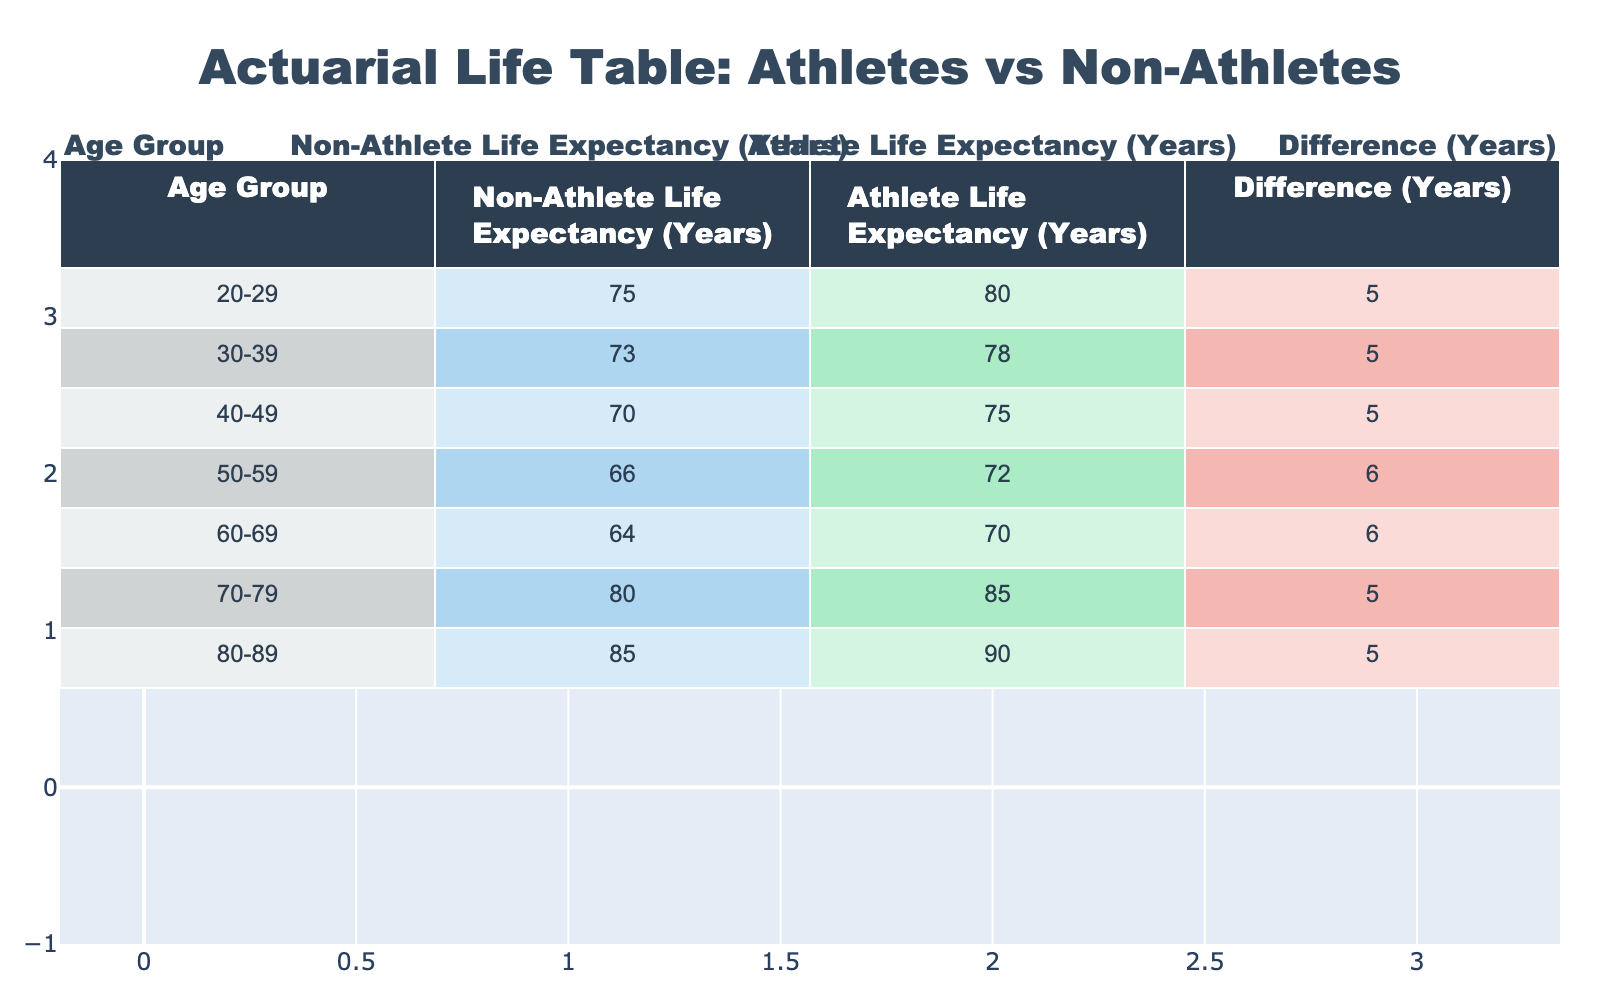What is the life expectancy of athletes in the age group 50-59? From the table, we can see the row corresponding to the age group 50-59. In that row, the value under "Athlete Life Expectancy" is 72 years.
Answer: 72 What is the life expectancy difference between athletes and non-athletes in the age group 30-39? In the table, for the age group 30-39, the "Difference" column shows a value of 5 years, indicating that athletes live 5 years longer on average than non-athletes in this age group.
Answer: 5 Is the life expectancy for non-athletes in the age group 60-69 greater than 65 years? Looking at the "Non-Athlete Life Expectancy" for the age group 60-69, the value is 64 years, which is less than 65. Therefore, the statement is false.
Answer: No Which age group shows the greatest difference in life expectancy between athletes and non-athletes? To find the greatest difference, we need to examine the "Difference" column and identify the maximum value. The maximum value is 6 years, seen in the age groups 50-59 and 60-69. Both groups reflect this greatest difference.
Answer: 50-59 and 60-69 What is the average life expectancy of non-athletes across all age groups? First, sum the non-athlete life expectancies: 75 + 73 + 70 + 66 + 64 + 80 + 85 = 513. There are 7 age groups, so to find the average, divide 513 by 7, giving about 73.29 years.
Answer: 73.29 Do athletes have a higher average life expectancy than non-athletes across all age groups combined? To compare averages, first find the total for athletes: 80 + 78 + 75 + 72 + 70 + 85 + 90 = 570, then divide by 7 to get 81.43. The total for non-athletes is 513 with an average of 73.29. Since 81.43 > 73.29, athletes do have a higher average life expectancy.
Answer: Yes How much longer, on average, do athletes live compared to non-athletes across all age groups presented? To find this, calculate the total difference: (5 + 5 + 5 + 6 + 6 + 5 + 5) = 37 years. Then, divide by the number of age groups (7) to find the average difference: 37 / 7 = approximately 5.29 years.
Answer: 5.29 Which life expectancy value is closest to the average life expectancy of both athletes and non-athletes combined in the age group 40-49? The life expectancy of athletes at this age is 75 and for non-athletes, it is 70. The combined average is (75 + 70) / 2 = 72.5 years. The value closest to this is 72 years for athletes.
Answer: 72 What is the life expectancy of non-athletes in the age group 70-79? In the table, the value for non-athletes in the age group 70-79 is clearly stated as 80 years.
Answer: 80 